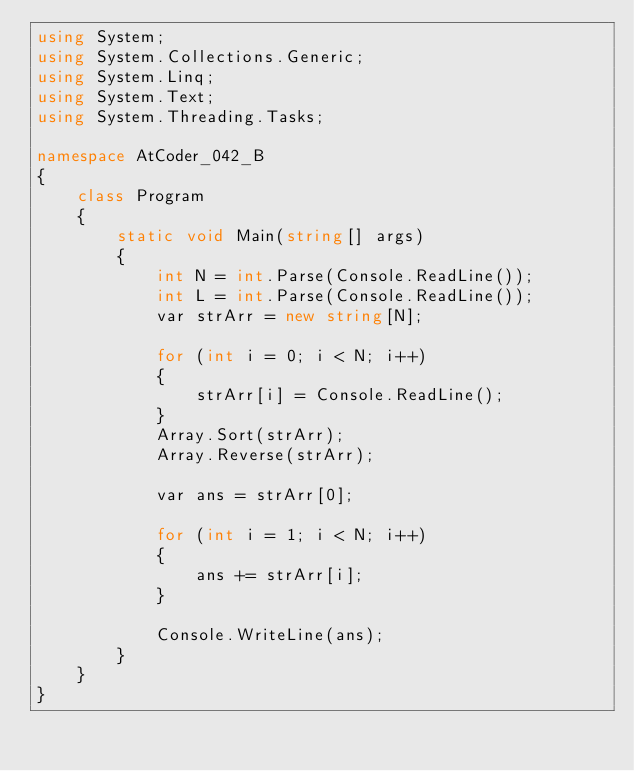Convert code to text. <code><loc_0><loc_0><loc_500><loc_500><_C#_>using System;
using System.Collections.Generic;
using System.Linq;
using System.Text;
using System.Threading.Tasks;

namespace AtCoder_042_B
{
    class Program
    {
        static void Main(string[] args)
        {
            int N = int.Parse(Console.ReadLine());
            int L = int.Parse(Console.ReadLine());
            var strArr = new string[N];

            for (int i = 0; i < N; i++)
            {
                strArr[i] = Console.ReadLine();
            }
            Array.Sort(strArr);
            Array.Reverse(strArr);

            var ans = strArr[0];

            for (int i = 1; i < N; i++)
            {
                ans += strArr[i];
            }

            Console.WriteLine(ans);
        }
    }
}
</code> 